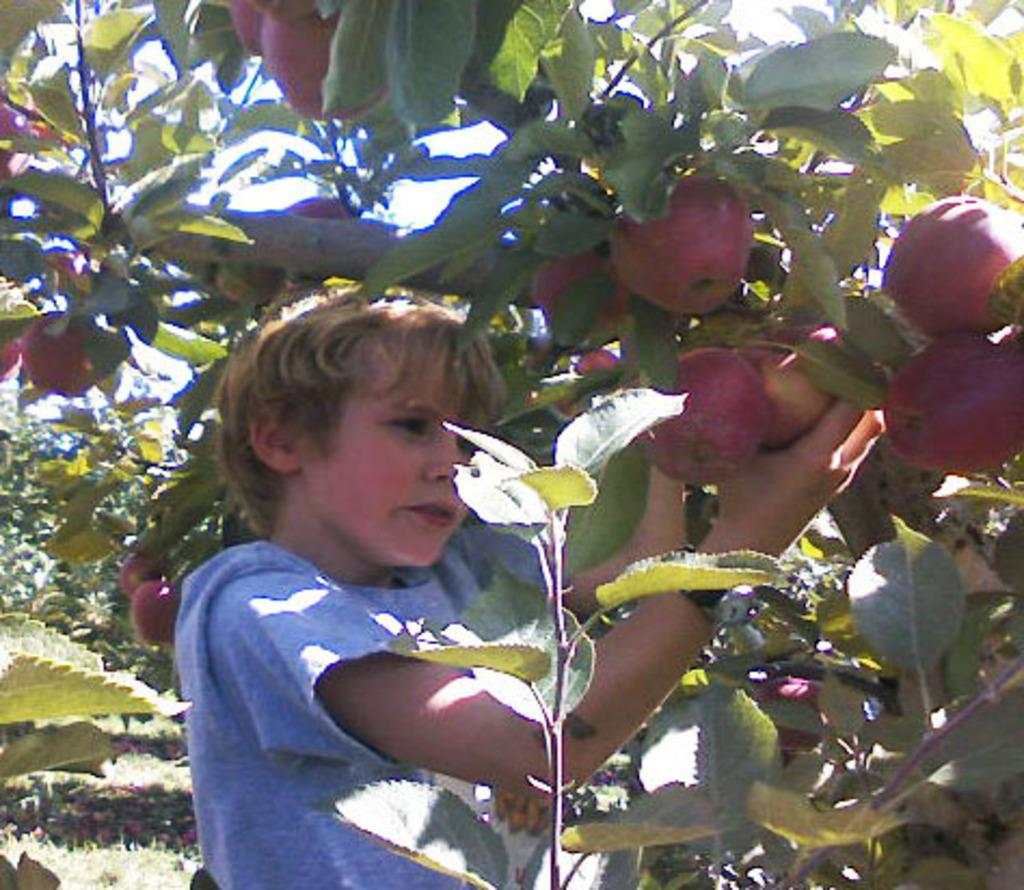Who is the main subject in the image? There is a boy in the image. What is the boy doing in the image? The boy is trying to pluck an apple from a tree. What type of trees are present in the image? There are apple trees in the image. How does the earthquake affect the boy's grip on the apple in the image? There is no earthquake present in the image, so its effect on the boy's grip cannot be determined. 